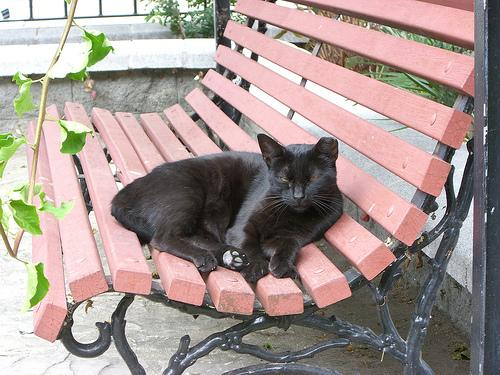Describe the location of the surfboard in relation to the other objects in the image. There are multiple instances of white surfboards in the water, independently located from the red wooden park bench and the cat. Count the number of red wood slats in the image and mention where they are located in relation to the park bench. There are 9 red wood slats located on the park bench; they are the seat and back support of the bench. What color and material is the park bench in the image? The park bench is red and made of wood. How many and which object(s) are interacting with the black cat in the image? One object, a red wooden park bench, is interacting with the black cat. Is there any presence of nature in the image, if so, what kind? Yes, there are low hanging leafy green tree branches and a plant on a vine with its stem at the left. What is the dominant emotion that can be associated with the image? A sense of tranquility and relaxation can be associated with the image. Identify the different objects within the image and provide an estimated count for each type. Red wooden park bench (1), red wood slats (9), white surfboards (9), black cat (1), stone wall (1), metal fence (1), leafy green tree branch (1), plant on a vine (1), and grey granite blocks (1). Perform a quality assessment for the image. What are the key elements? The image has high quality with clear and sharp objects, accurate colors, balanced composition, and a detailed description of various elements. Describe any complex reasoning you can infer from the image based on the objects and their relationships. The image portrays a serene outdoor setting with a black cat on a red wooden park bench, surrounded by nature and water, potentially indicating a peaceful coexistence of urban furniture and natural elements in the environment. Identify the main object in the picture and describe its appearance. The main object is a red wooden park bench with curved wooden slats and a metal fence above a stone wall. 